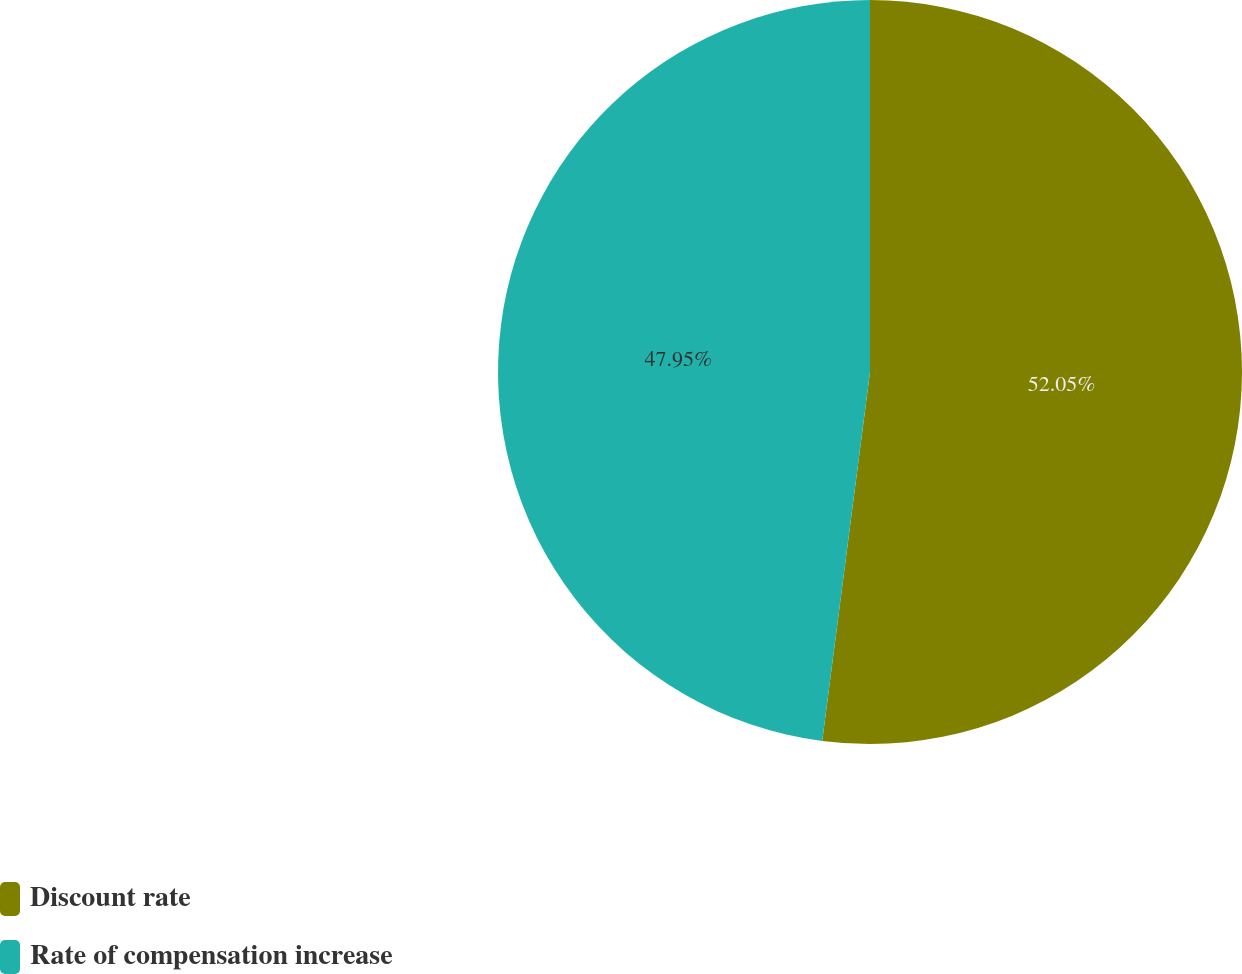<chart> <loc_0><loc_0><loc_500><loc_500><pie_chart><fcel>Discount rate<fcel>Rate of compensation increase<nl><fcel>52.05%<fcel>47.95%<nl></chart> 